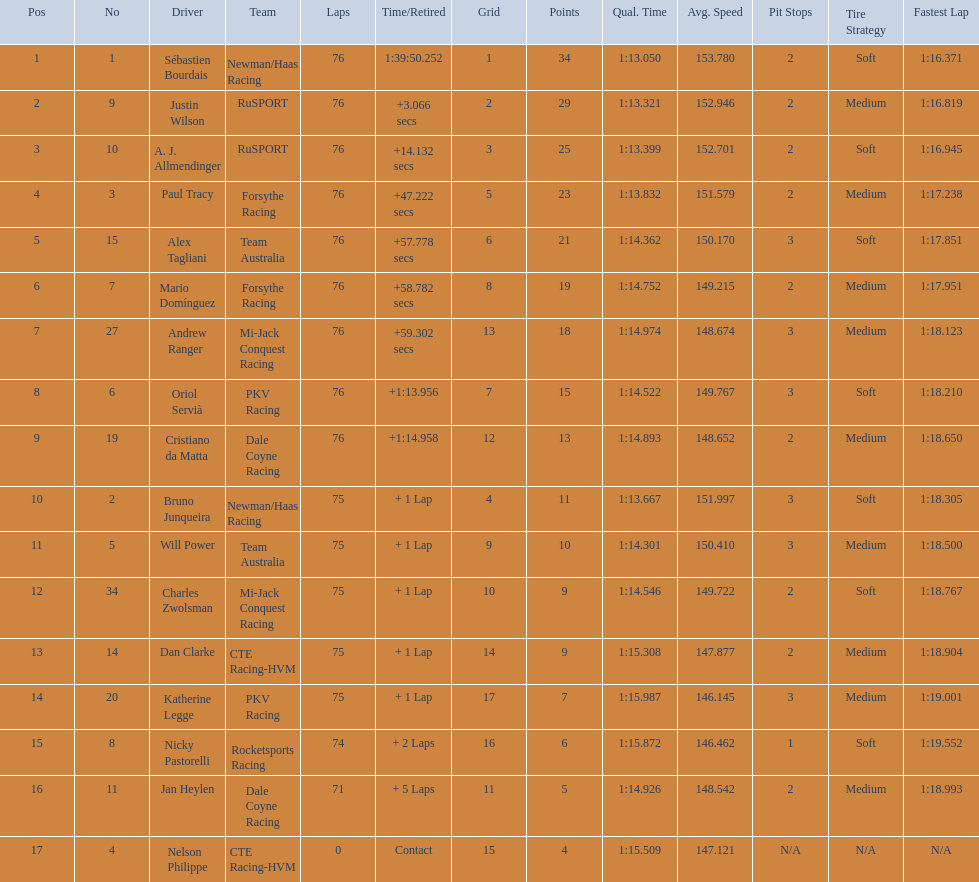Which drivers completed all 76 laps? Sébastien Bourdais, Justin Wilson, A. J. Allmendinger, Paul Tracy, Alex Tagliani, Mario Domínguez, Andrew Ranger, Oriol Servià, Cristiano da Matta. Of these drivers, which ones finished less than a minute behind first place? Paul Tracy, Alex Tagliani, Mario Domínguez, Andrew Ranger. Of these drivers, which ones finished with a time less than 50 seconds behind first place? Justin Wilson, A. J. Allmendinger, Paul Tracy. Of these three drivers, who finished last? Paul Tracy. 